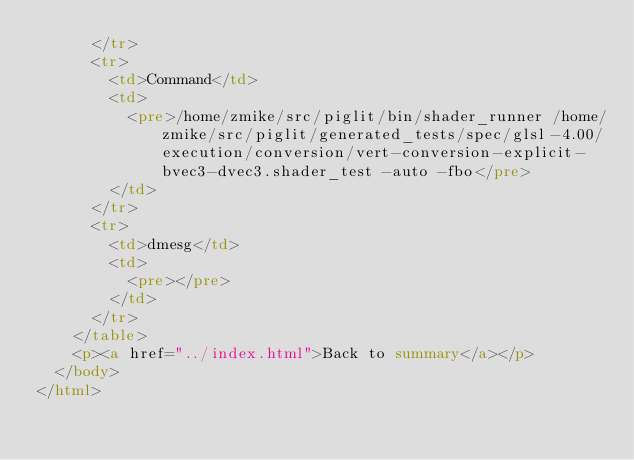<code> <loc_0><loc_0><loc_500><loc_500><_HTML_>      </tr>
      <tr>
        <td>Command</td>
        <td>
          <pre>/home/zmike/src/piglit/bin/shader_runner /home/zmike/src/piglit/generated_tests/spec/glsl-4.00/execution/conversion/vert-conversion-explicit-bvec3-dvec3.shader_test -auto -fbo</pre>
        </td>
      </tr>
      <tr>
        <td>dmesg</td>
        <td>
          <pre></pre>
        </td>
      </tr>
    </table>
    <p><a href="../index.html">Back to summary</a></p>
  </body>
</html>
</code> 